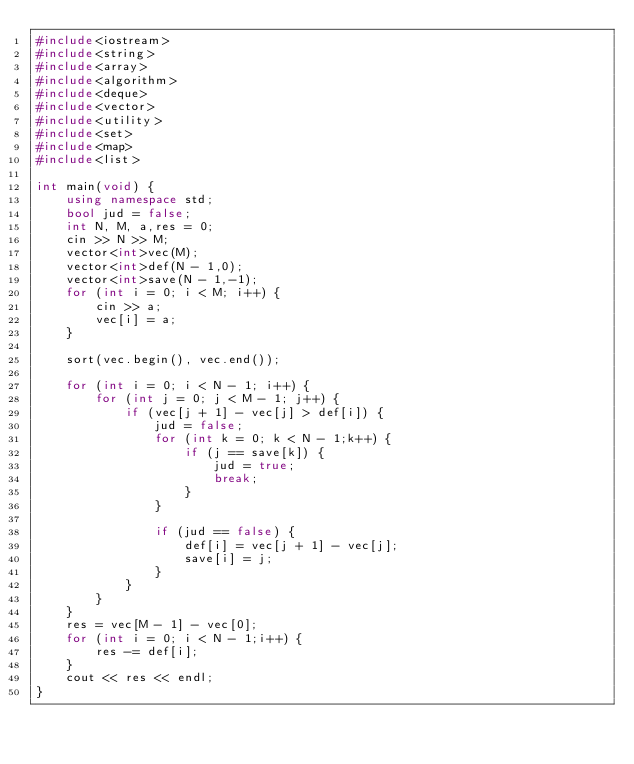<code> <loc_0><loc_0><loc_500><loc_500><_C++_>#include<iostream>
#include<string>
#include<array>
#include<algorithm>
#include<deque>
#include<vector>
#include<utility>
#include<set>
#include<map>
#include<list>

int main(void) {
	using namespace std;
	bool jud = false;
	int N, M, a,res = 0;
	cin >> N >> M;
	vector<int>vec(M);
	vector<int>def(N - 1,0);
	vector<int>save(N - 1,-1);
	for (int i = 0; i < M; i++) {
		cin >> a;
		vec[i] = a;
	}

	sort(vec.begin(), vec.end());

	for (int i = 0; i < N - 1; i++) {
		for (int j = 0; j < M - 1; j++) {
			if (vec[j + 1] - vec[j] > def[i]) {
				jud = false;
				for (int k = 0; k < N - 1;k++) {
					if (j == save[k]) {
						jud = true;
						break;
					}
				}

				if (jud == false) {
					def[i] = vec[j + 1] - vec[j];
					save[i] = j;
				}
			}
		}
	}
	res = vec[M - 1] - vec[0];
	for (int i = 0; i < N - 1;i++) {
		res -= def[i];
	}
	cout << res << endl;
}</code> 